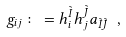Convert formula to latex. <formula><loc_0><loc_0><loc_500><loc_500>g _ { i j } \colon = h _ { i } ^ { \tilde { I } } h _ { j } ^ { \tilde { J } } a _ { \tilde { I } \tilde { J } } \ ,</formula> 